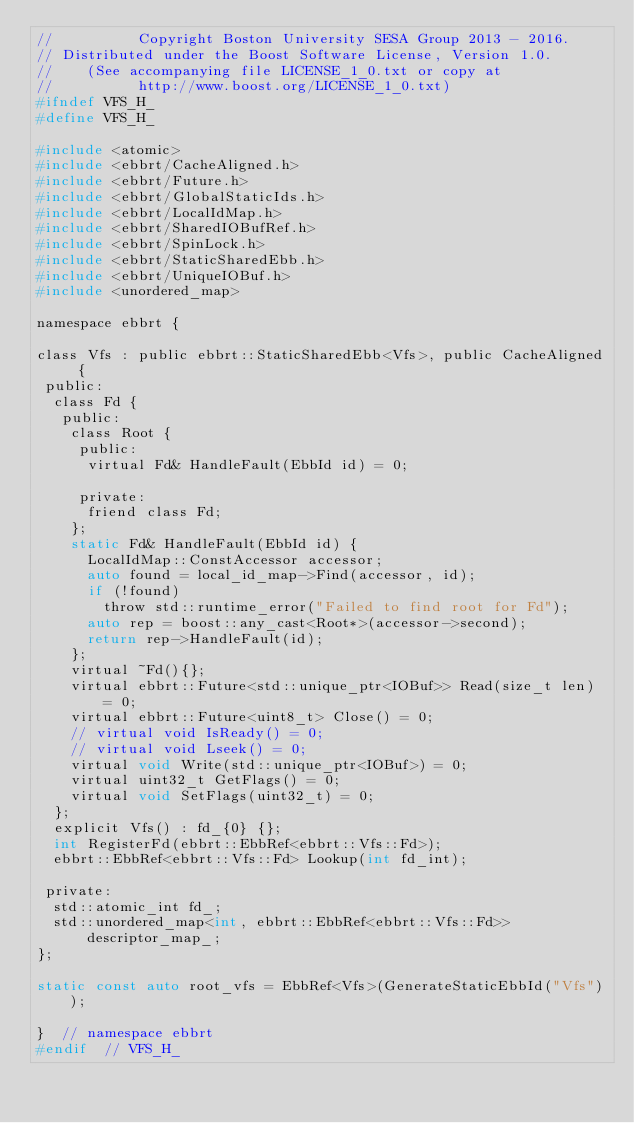Convert code to text. <code><loc_0><loc_0><loc_500><loc_500><_C_>//          Copyright Boston University SESA Group 2013 - 2016.
// Distributed under the Boost Software License, Version 1.0.
//    (See accompanying file LICENSE_1_0.txt or copy at
//          http://www.boost.org/LICENSE_1_0.txt)
#ifndef VFS_H_
#define VFS_H_

#include <atomic>
#include <ebbrt/CacheAligned.h>
#include <ebbrt/Future.h>
#include <ebbrt/GlobalStaticIds.h>
#include <ebbrt/LocalIdMap.h>
#include <ebbrt/SharedIOBufRef.h>
#include <ebbrt/SpinLock.h>
#include <ebbrt/StaticSharedEbb.h>
#include <ebbrt/UniqueIOBuf.h>
#include <unordered_map>

namespace ebbrt {

class Vfs : public ebbrt::StaticSharedEbb<Vfs>, public CacheAligned {
 public:
  class Fd {
   public:
    class Root {
     public:
      virtual Fd& HandleFault(EbbId id) = 0;

     private:
      friend class Fd;
    };
    static Fd& HandleFault(EbbId id) {
      LocalIdMap::ConstAccessor accessor;
      auto found = local_id_map->Find(accessor, id);
      if (!found)
        throw std::runtime_error("Failed to find root for Fd");
      auto rep = boost::any_cast<Root*>(accessor->second);
      return rep->HandleFault(id);
    };
    virtual ~Fd(){};
    virtual ebbrt::Future<std::unique_ptr<IOBuf>> Read(size_t len) = 0;
    virtual ebbrt::Future<uint8_t> Close() = 0;
    // virtual void IsReady() = 0;
    // virtual void Lseek() = 0;
    virtual void Write(std::unique_ptr<IOBuf>) = 0;
    virtual uint32_t GetFlags() = 0;
    virtual void SetFlags(uint32_t) = 0;
  };
  explicit Vfs() : fd_{0} {};
  int RegisterFd(ebbrt::EbbRef<ebbrt::Vfs::Fd>);
  ebbrt::EbbRef<ebbrt::Vfs::Fd> Lookup(int fd_int);

 private:
  std::atomic_int fd_;
  std::unordered_map<int, ebbrt::EbbRef<ebbrt::Vfs::Fd>> descriptor_map_;
};

static const auto root_vfs = EbbRef<Vfs>(GenerateStaticEbbId("Vfs"));

}  // namespace ebbrt
#endif  // VFS_H_
</code> 